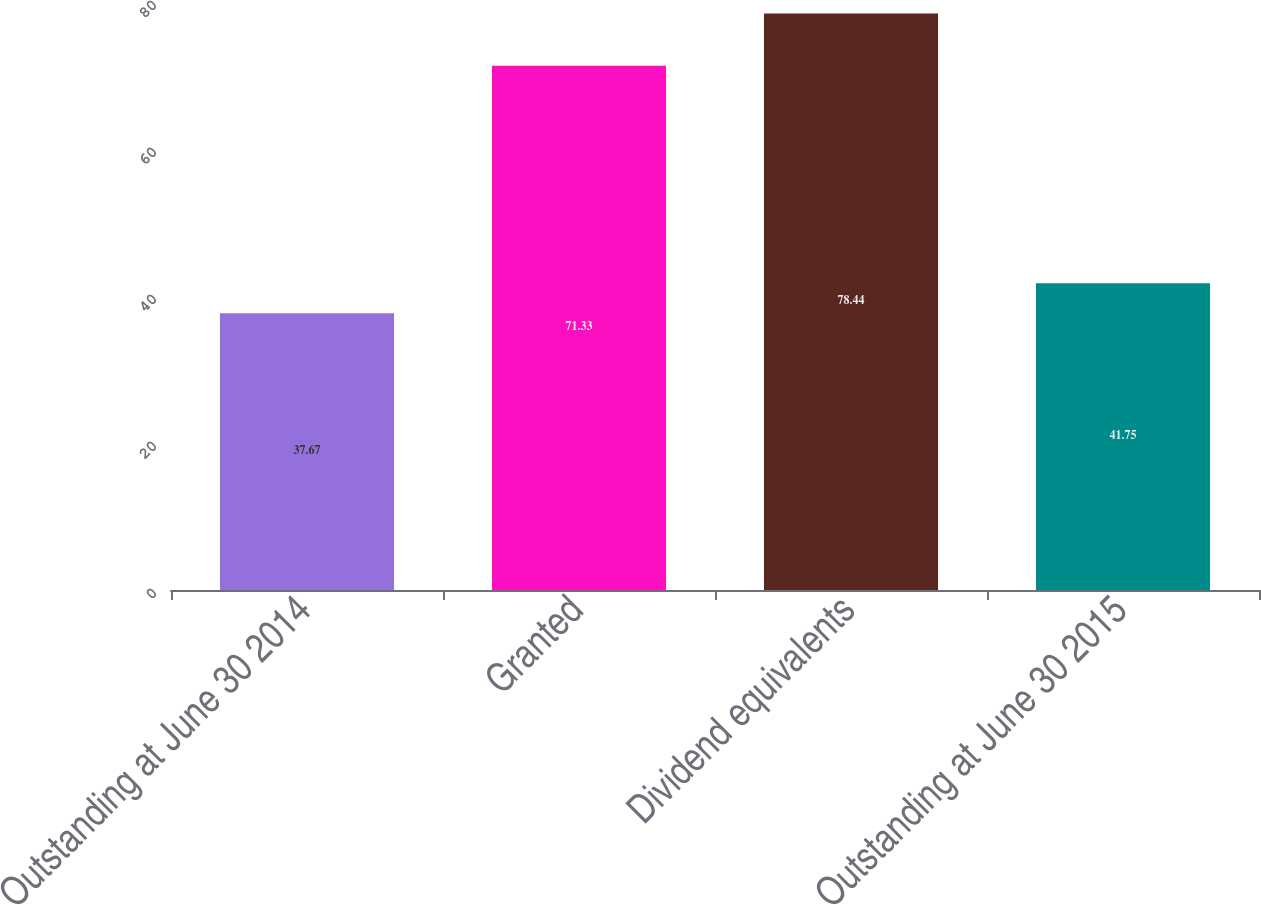Convert chart to OTSL. <chart><loc_0><loc_0><loc_500><loc_500><bar_chart><fcel>Outstanding at June 30 2014<fcel>Granted<fcel>Dividend equivalents<fcel>Outstanding at June 30 2015<nl><fcel>37.67<fcel>71.33<fcel>78.44<fcel>41.75<nl></chart> 